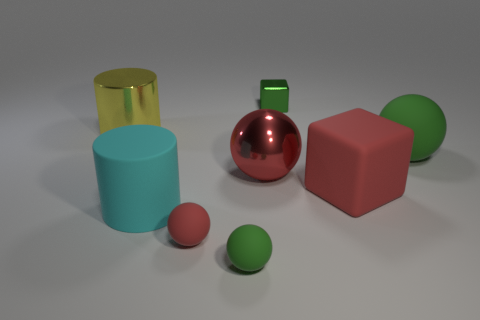Is the number of tiny shiny blocks that are in front of the large red shiny thing greater than the number of gray matte cubes?
Give a very brief answer. No. There is a rubber object behind the cube in front of the rubber sphere that is on the right side of the tiny green block; what is its shape?
Offer a very short reply. Sphere. There is a green rubber object to the right of the red matte block; is it the same size as the big yellow thing?
Keep it short and to the point. Yes. There is a metallic thing that is both behind the large red ball and on the right side of the red rubber ball; what is its shape?
Give a very brief answer. Cube. Does the shiny block have the same color as the large sphere that is left of the large green matte sphere?
Give a very brief answer. No. What color is the large rubber cube behind the matte object that is left of the tiny red matte object that is in front of the big matte cube?
Your answer should be compact. Red. What color is the other thing that is the same shape as the big cyan object?
Your answer should be compact. Yellow. Is the number of red things that are behind the large cyan rubber cylinder the same as the number of green matte spheres?
Offer a very short reply. Yes. How many spheres are either green rubber objects or small green things?
Provide a short and direct response. 2. What is the color of the big block that is the same material as the large cyan thing?
Your answer should be compact. Red. 